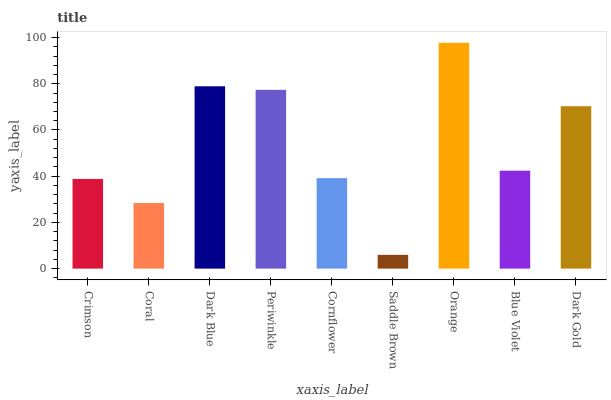Is Saddle Brown the minimum?
Answer yes or no. Yes. Is Orange the maximum?
Answer yes or no. Yes. Is Coral the minimum?
Answer yes or no. No. Is Coral the maximum?
Answer yes or no. No. Is Crimson greater than Coral?
Answer yes or no. Yes. Is Coral less than Crimson?
Answer yes or no. Yes. Is Coral greater than Crimson?
Answer yes or no. No. Is Crimson less than Coral?
Answer yes or no. No. Is Blue Violet the high median?
Answer yes or no. Yes. Is Blue Violet the low median?
Answer yes or no. Yes. Is Coral the high median?
Answer yes or no. No. Is Dark Gold the low median?
Answer yes or no. No. 